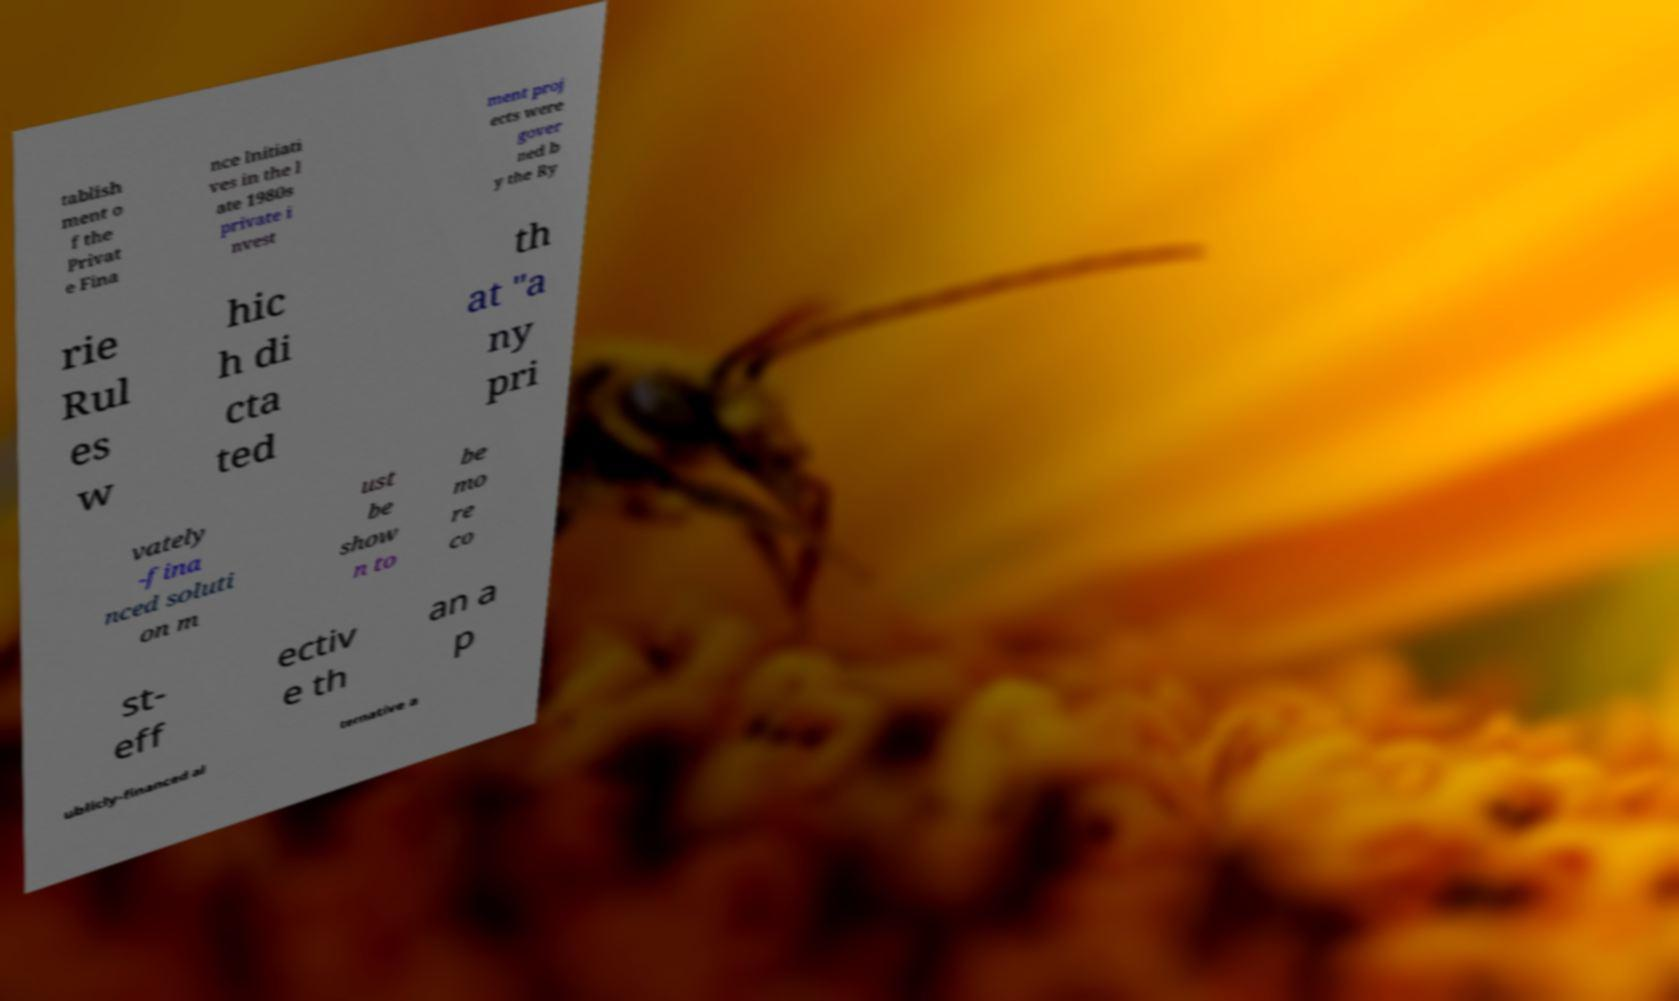I need the written content from this picture converted into text. Can you do that? tablish ment o f the Privat e Fina nce Initiati ves in the l ate 1980s private i nvest ment proj ects were gover ned b y the Ry rie Rul es w hic h di cta ted th at "a ny pri vately -fina nced soluti on m ust be show n to be mo re co st- eff ectiv e th an a p ublicly-financed al ternative a 